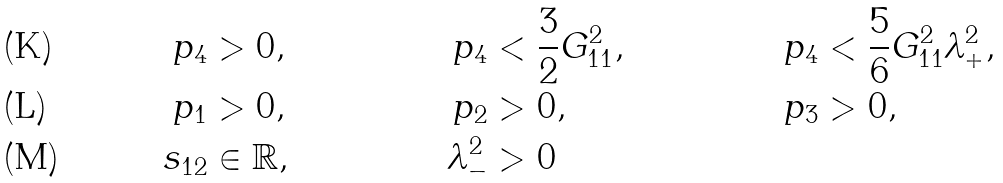Convert formula to latex. <formula><loc_0><loc_0><loc_500><loc_500>p _ { 4 } & > 0 , & p _ { 4 } & < \frac { 3 } { 2 } G _ { 1 1 } ^ { 2 } , & p _ { 4 } & < \frac { 5 } { 6 } G _ { 1 1 } ^ { 2 } \lambda _ { + } ^ { 2 } , \\ p _ { 1 } & > 0 , & p _ { 2 } & > 0 , & p _ { 3 } & > 0 , \\ s _ { 1 2 } & \in \mathbb { R } , & \lambda _ { - } ^ { 2 } & > 0</formula> 